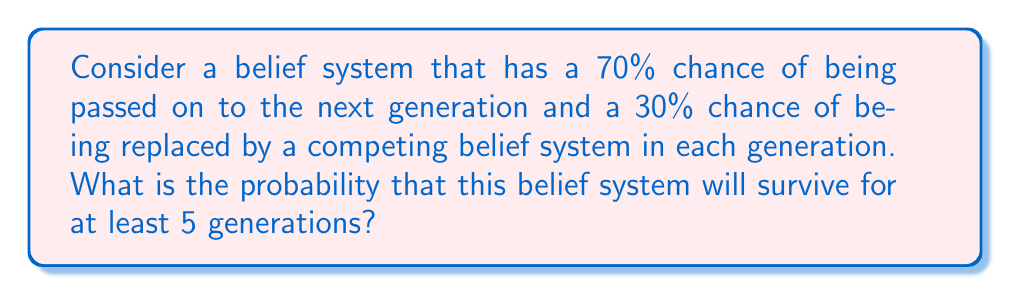Help me with this question. To solve this problem, we need to consider the probability of the belief system surviving each generation and then calculate the cumulative probability of it surviving for all 5 generations.

Step 1: Identify the probability of survival for each generation
The probability of survival for each generation is given as 70% or 0.7.

Step 2: Calculate the probability of surviving all 5 generations
Since the events of surviving each generation are independent, we can multiply the probabilities:

$$P(\text{surviving 5 generations}) = 0.7 \times 0.7 \times 0.7 \times 0.7 \times 0.7 = 0.7^5$$

Step 3: Compute the final probability
$$0.7^5 = 0.16807$$

Therefore, the probability that the belief system will survive for at least 5 generations is approximately 0.16807 or 16.807%.

This problem relates to the philosophical concept of cultural transmission and the resilience of belief systems over time. It demonstrates how even a relatively high probability of transmission for each generation can result in a much lower probability of long-term survival, which may prompt ethical considerations about the preservation and evolution of belief systems.
Answer: $0.16807$ or $16.807\%$ 